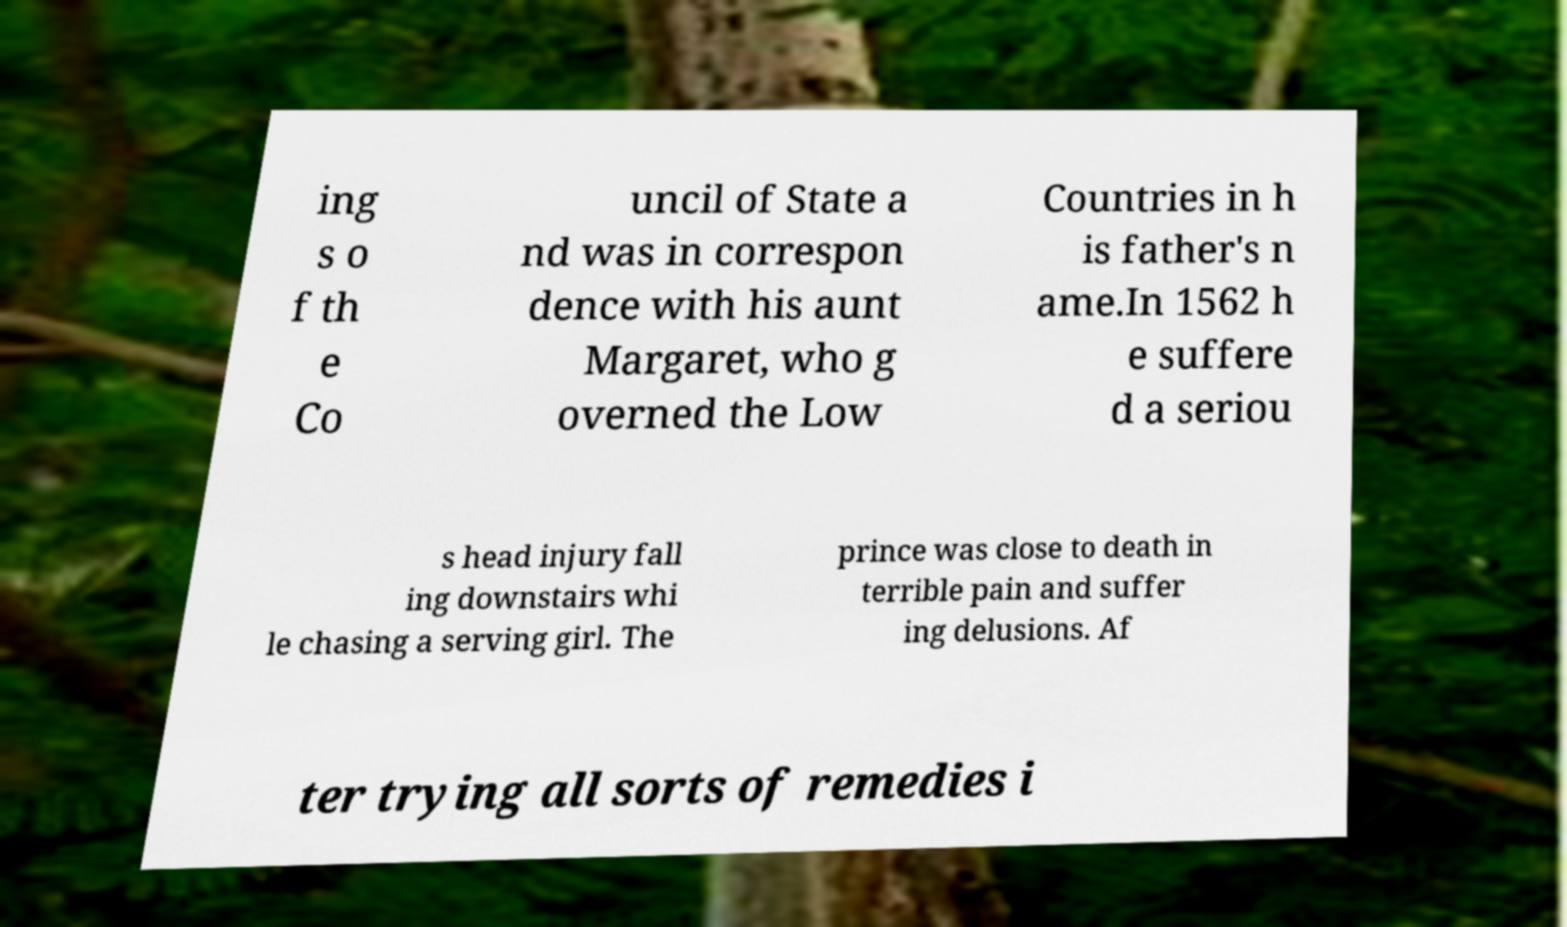I need the written content from this picture converted into text. Can you do that? ing s o f th e Co uncil of State a nd was in correspon dence with his aunt Margaret, who g overned the Low Countries in h is father's n ame.In 1562 h e suffere d a seriou s head injury fall ing downstairs whi le chasing a serving girl. The prince was close to death in terrible pain and suffer ing delusions. Af ter trying all sorts of remedies i 